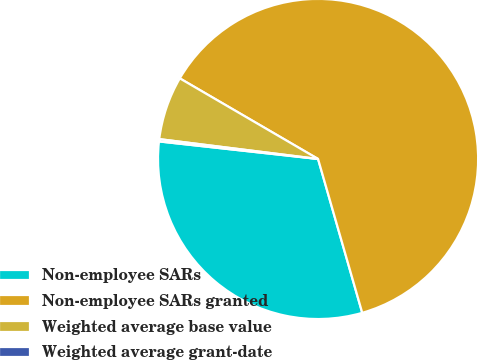<chart> <loc_0><loc_0><loc_500><loc_500><pie_chart><fcel>Non-employee SARs<fcel>Non-employee SARs granted<fcel>Weighted average base value<fcel>Weighted average grant-date<nl><fcel>31.2%<fcel>62.15%<fcel>6.42%<fcel>0.23%<nl></chart> 